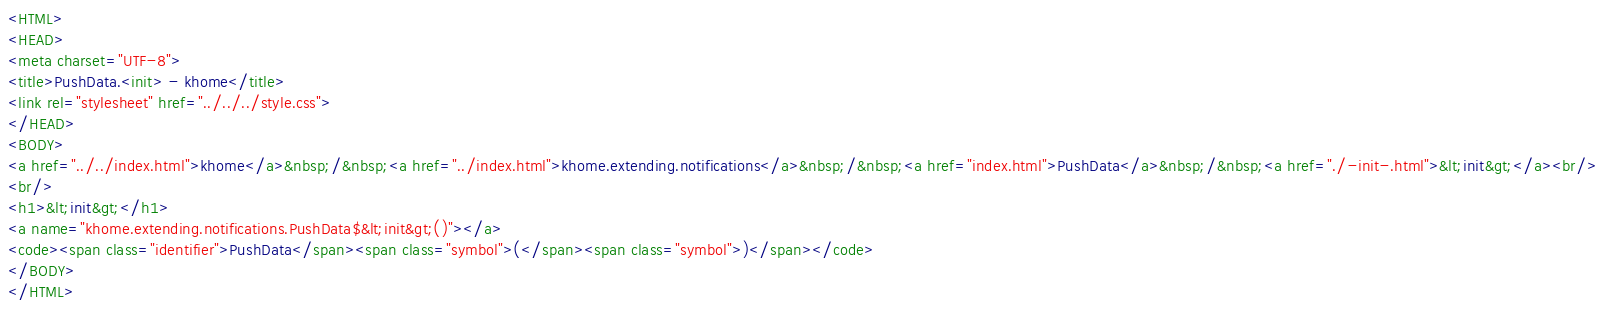Convert code to text. <code><loc_0><loc_0><loc_500><loc_500><_HTML_><HTML>
<HEAD>
<meta charset="UTF-8">
<title>PushData.<init> - khome</title>
<link rel="stylesheet" href="../../../style.css">
</HEAD>
<BODY>
<a href="../../index.html">khome</a>&nbsp;/&nbsp;<a href="../index.html">khome.extending.notifications</a>&nbsp;/&nbsp;<a href="index.html">PushData</a>&nbsp;/&nbsp;<a href="./-init-.html">&lt;init&gt;</a><br/>
<br/>
<h1>&lt;init&gt;</h1>
<a name="khome.extending.notifications.PushData$&lt;init&gt;()"></a>
<code><span class="identifier">PushData</span><span class="symbol">(</span><span class="symbol">)</span></code>
</BODY>
</HTML>
</code> 